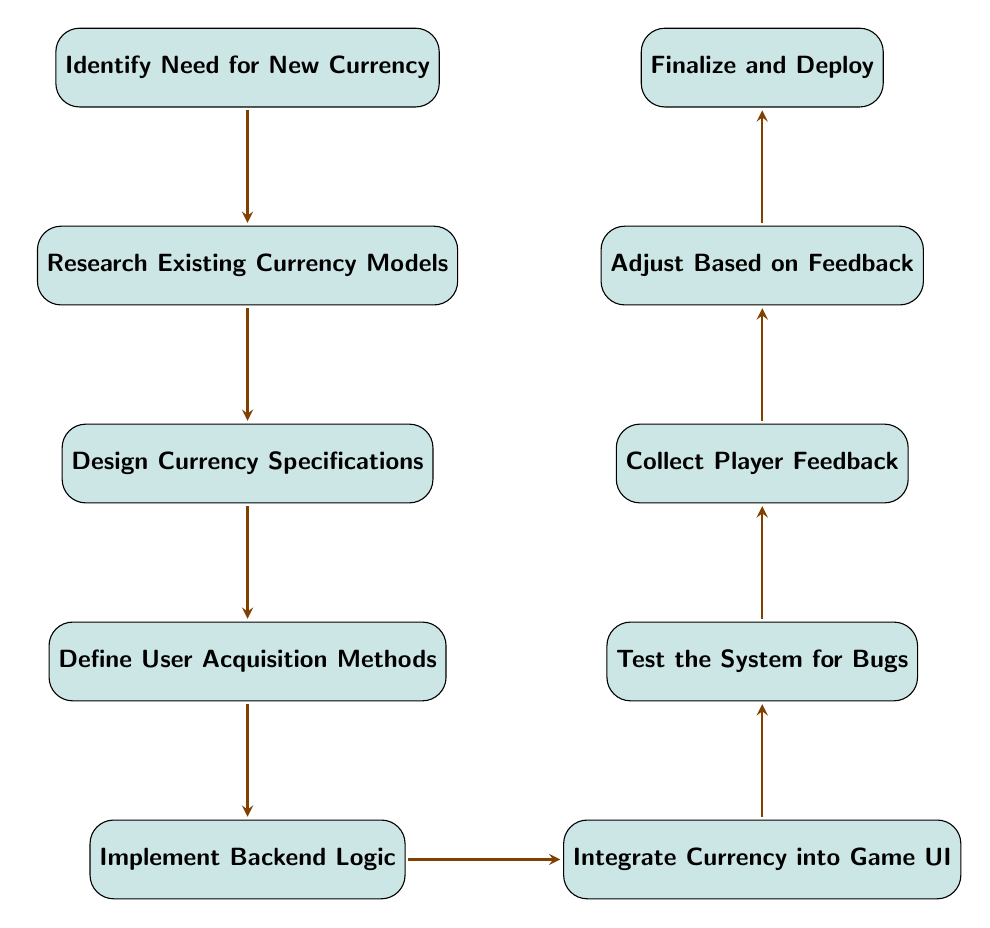What is the first step in the workflow? The first node in the diagram is "Identify Need for New Currency", which represents the beginning of the workflow for implementing the new currency system.
Answer: Identify Need for New Currency How many steps are there in total? The diagram has a total of 10 nodes, each representing a step in the workflow process.
Answer: 10 What comes immediately after “Design Currency Specifications”? The diagram shows that "Define User Acquisition Methods" is the next node that follows "Design Currency Specifications", indicating what step comes after designing the currency specifications.
Answer: Define User Acquisition Methods Which nodes are connected to “Integrate Currency into Game UI”? The edges indicate that "Implement Backend Logic" leads directly to "Integrate Currency into Game UI", making it the only preceding node connected to it. Conversely, it is connected to "Test the System for Bugs" immediately after.
Answer: Implement Backend Logic, Test the System for Bugs What is the final step in the workflow? At the bottom of the flow chart, the last node is "Finalize and Deploy", indicating that this is the final step in the workflow process for implementing a new currency system.
Answer: Finalize and Deploy Which step follows “Collect Player Feedback”? The diagram shows that "Adjust Based on Feedback" follows "Collect Player Feedback", representing the step where adjustments are made based on the feedback collected from players.
Answer: Adjust Based on Feedback If a bug is found during testing, which step will be revisited? According to the flow, if a bug is detected during "Test the System for Bugs", it does not lead directly back to an earlier step, thus indicating that the workflow will need reassessment, potentially revisiting "Implement Backend Logic".
Answer: Implement Backend Logic What step requires user interaction? The node labeled "Collect Player Feedback" specifically involves user interaction and feedback, making it a key part of the workflow that requires input from players.
Answer: Collect Player Feedback Which step includes integrating the new currency visually? "Integrate Currency into Game UI" is the node that describes the step in which the new currency system is visually incorporated into the game's user interface.
Answer: Integrate Currency into Game UI 